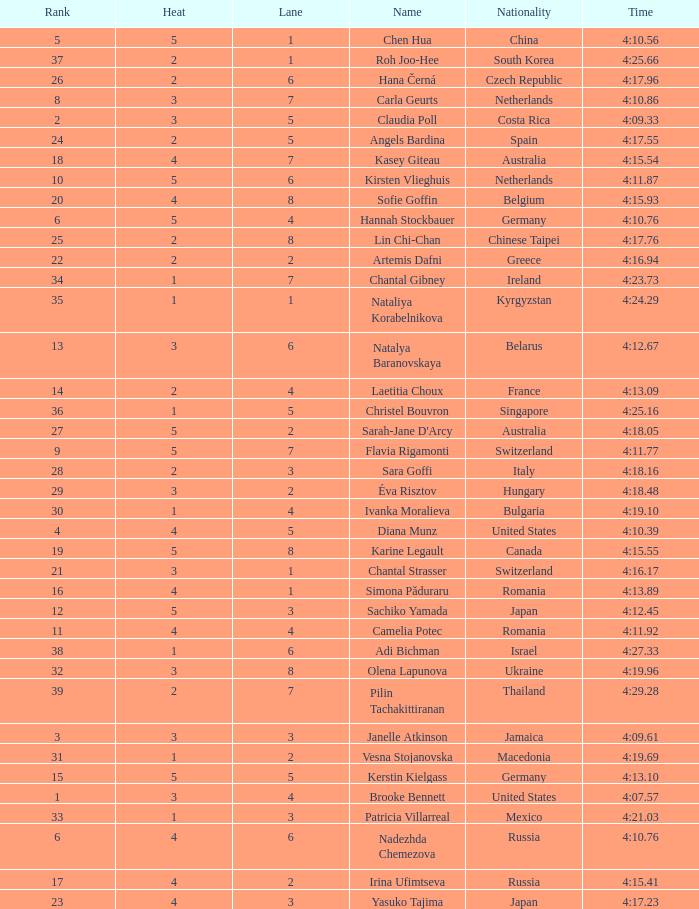Could you parse the entire table as a dict? {'header': ['Rank', 'Heat', 'Lane', 'Name', 'Nationality', 'Time'], 'rows': [['5', '5', '1', 'Chen Hua', 'China', '4:10.56'], ['37', '2', '1', 'Roh Joo-Hee', 'South Korea', '4:25.66'], ['26', '2', '6', 'Hana Černá', 'Czech Republic', '4:17.96'], ['8', '3', '7', 'Carla Geurts', 'Netherlands', '4:10.86'], ['2', '3', '5', 'Claudia Poll', 'Costa Rica', '4:09.33'], ['24', '2', '5', 'Angels Bardina', 'Spain', '4:17.55'], ['18', '4', '7', 'Kasey Giteau', 'Australia', '4:15.54'], ['10', '5', '6', 'Kirsten Vlieghuis', 'Netherlands', '4:11.87'], ['20', '4', '8', 'Sofie Goffin', 'Belgium', '4:15.93'], ['6', '5', '4', 'Hannah Stockbauer', 'Germany', '4:10.76'], ['25', '2', '8', 'Lin Chi-Chan', 'Chinese Taipei', '4:17.76'], ['22', '2', '2', 'Artemis Dafni', 'Greece', '4:16.94'], ['34', '1', '7', 'Chantal Gibney', 'Ireland', '4:23.73'], ['35', '1', '1', 'Nataliya Korabelnikova', 'Kyrgyzstan', '4:24.29'], ['13', '3', '6', 'Natalya Baranovskaya', 'Belarus', '4:12.67'], ['14', '2', '4', 'Laetitia Choux', 'France', '4:13.09'], ['36', '1', '5', 'Christel Bouvron', 'Singapore', '4:25.16'], ['27', '5', '2', "Sarah-Jane D'Arcy", 'Australia', '4:18.05'], ['9', '5', '7', 'Flavia Rigamonti', 'Switzerland', '4:11.77'], ['28', '2', '3', 'Sara Goffi', 'Italy', '4:18.16'], ['29', '3', '2', 'Éva Risztov', 'Hungary', '4:18.48'], ['30', '1', '4', 'Ivanka Moralieva', 'Bulgaria', '4:19.10'], ['4', '4', '5', 'Diana Munz', 'United States', '4:10.39'], ['19', '5', '8', 'Karine Legault', 'Canada', '4:15.55'], ['21', '3', '1', 'Chantal Strasser', 'Switzerland', '4:16.17'], ['16', '4', '1', 'Simona Păduraru', 'Romania', '4:13.89'], ['12', '5', '3', 'Sachiko Yamada', 'Japan', '4:12.45'], ['11', '4', '4', 'Camelia Potec', 'Romania', '4:11.92'], ['38', '1', '6', 'Adi Bichman', 'Israel', '4:27.33'], ['32', '3', '8', 'Olena Lapunova', 'Ukraine', '4:19.96'], ['39', '2', '7', 'Pilin Tachakittiranan', 'Thailand', '4:29.28'], ['3', '3', '3', 'Janelle Atkinson', 'Jamaica', '4:09.61'], ['31', '1', '2', 'Vesna Stojanovska', 'Macedonia', '4:19.69'], ['15', '5', '5', 'Kerstin Kielgass', 'Germany', '4:13.10'], ['1', '3', '4', 'Brooke Bennett', 'United States', '4:07.57'], ['33', '1', '3', 'Patricia Villarreal', 'Mexico', '4:21.03'], ['6', '4', '6', 'Nadezhda Chemezova', 'Russia', '4:10.76'], ['17', '4', '2', 'Irina Ufimtseva', 'Russia', '4:15.41'], ['23', '4', '3', 'Yasuko Tajima', 'Japan', '4:17.23']]} Name the average rank with larger than 3 and heat more than 5 None. 